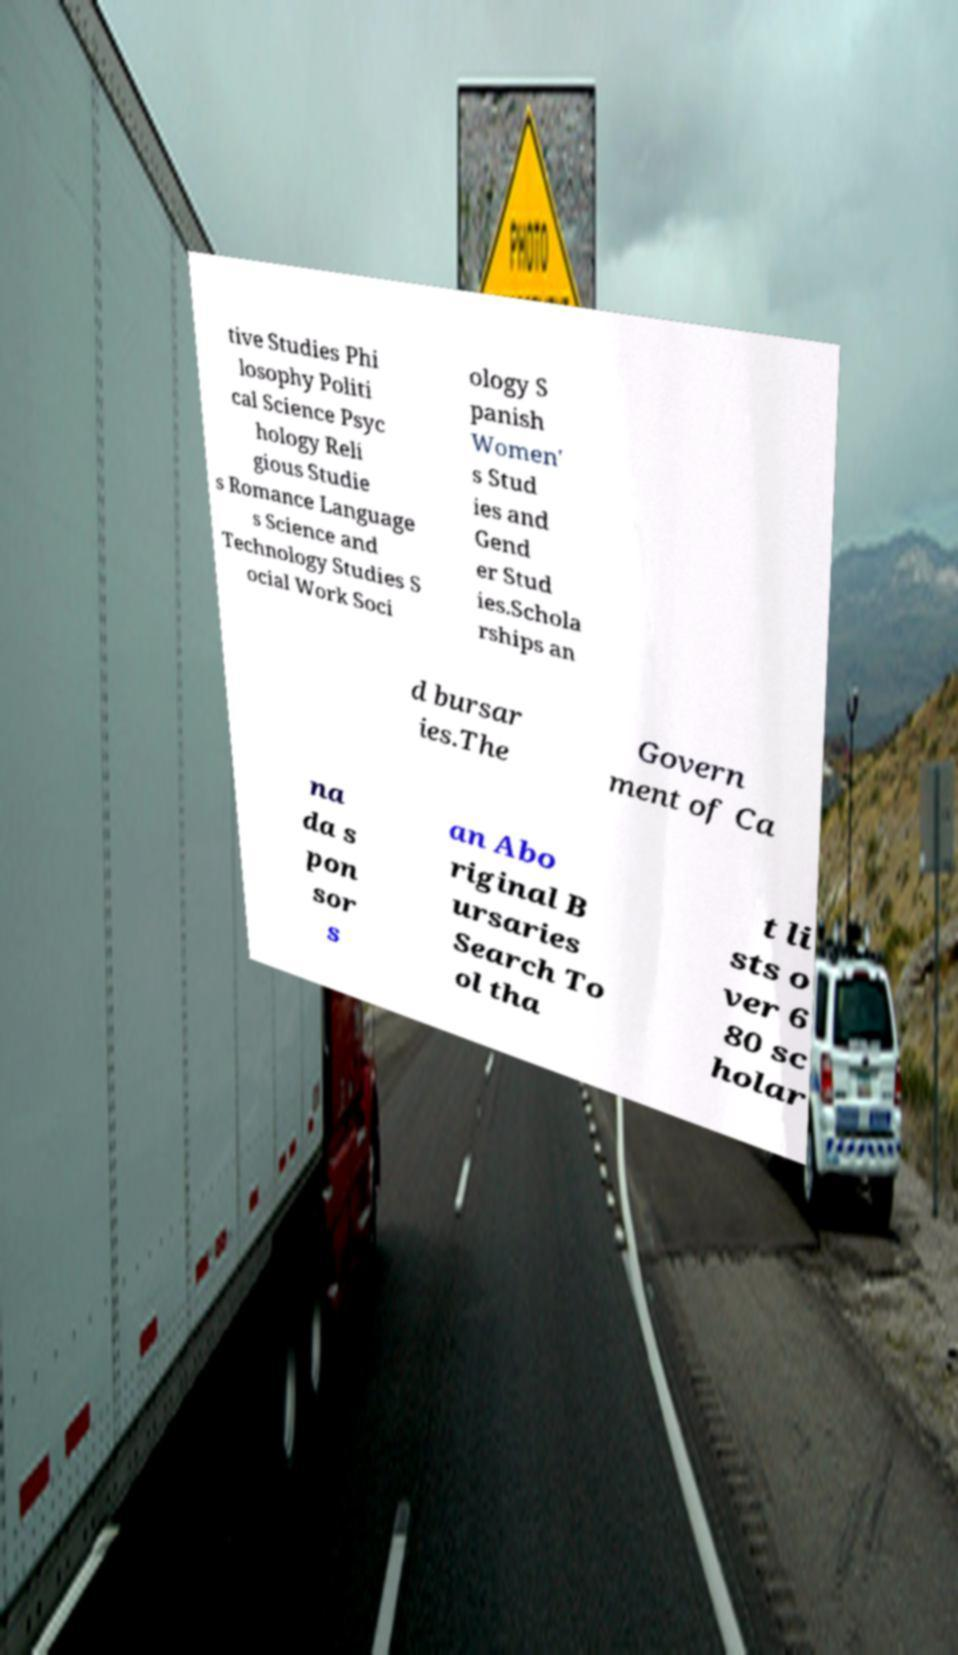There's text embedded in this image that I need extracted. Can you transcribe it verbatim? tive Studies Phi losophy Politi cal Science Psyc hology Reli gious Studie s Romance Language s Science and Technology Studies S ocial Work Soci ology S panish Women' s Stud ies and Gend er Stud ies.Schola rships an d bursar ies.The Govern ment of Ca na da s pon sor s an Abo riginal B ursaries Search To ol tha t li sts o ver 6 80 sc holar 